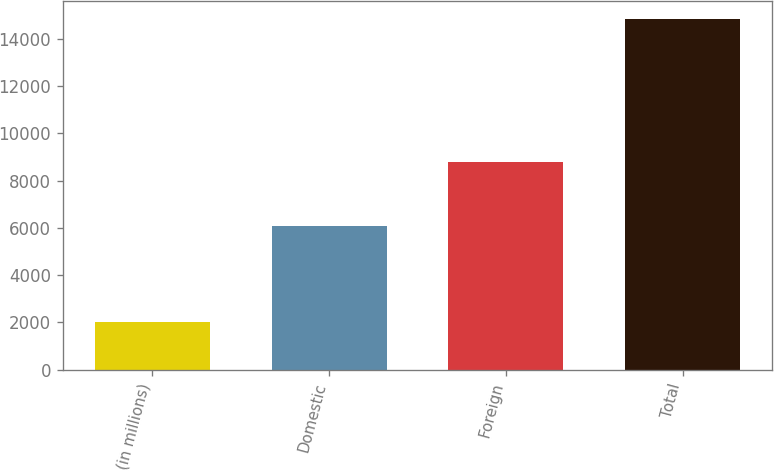<chart> <loc_0><loc_0><loc_500><loc_500><bar_chart><fcel>(in millions)<fcel>Domestic<fcel>Foreign<fcel>Total<nl><fcel>2004<fcel>6069<fcel>8776<fcel>14845<nl></chart> 